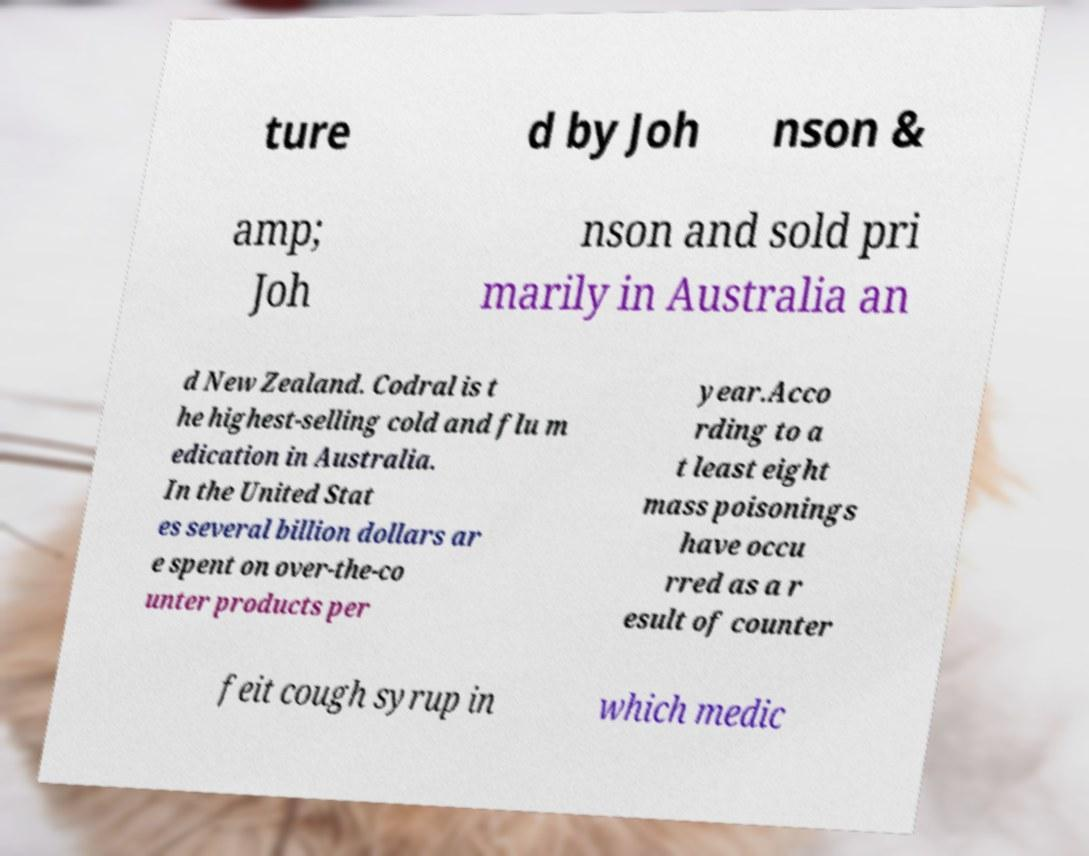Can you accurately transcribe the text from the provided image for me? ture d by Joh nson & amp; Joh nson and sold pri marily in Australia an d New Zealand. Codral is t he highest-selling cold and flu m edication in Australia. In the United Stat es several billion dollars ar e spent on over-the-co unter products per year.Acco rding to a t least eight mass poisonings have occu rred as a r esult of counter feit cough syrup in which medic 